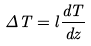Convert formula to latex. <formula><loc_0><loc_0><loc_500><loc_500>\Delta T = l \frac { d T } { d z }</formula> 